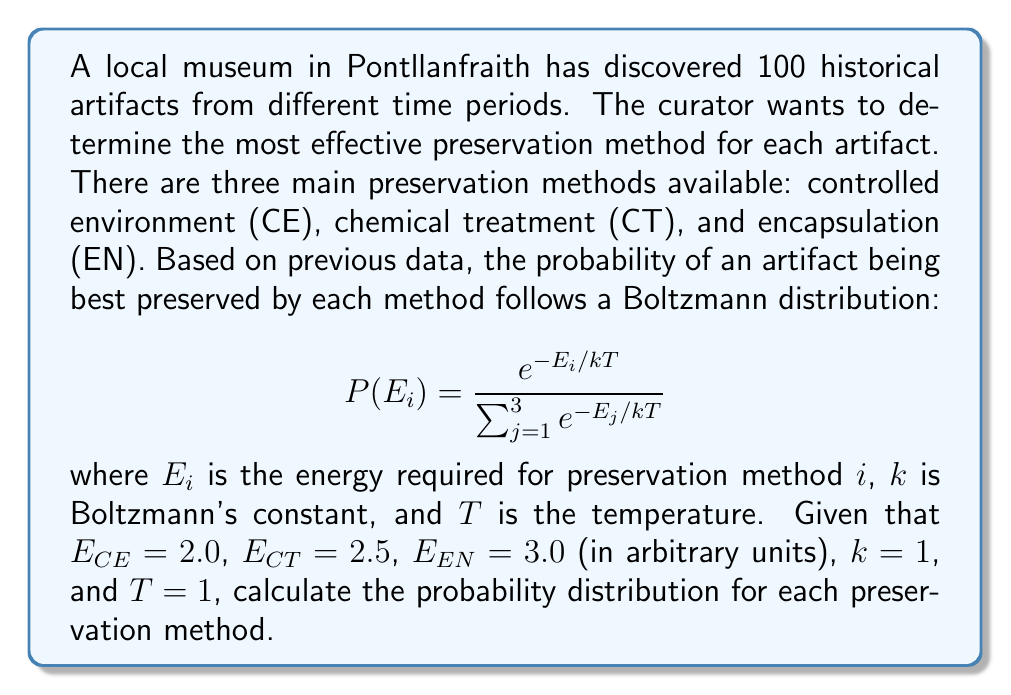Provide a solution to this math problem. To solve this problem, we need to follow these steps:

1. Calculate the denominator (partition function) of the Boltzmann distribution:
   $$Z = \sum_{j=1}^3 e^{-E_j/kT} = e^{-E_{CE}/kT} + e^{-E_{CT}/kT} + e^{-E_{EN}/kT}$$

2. Calculate the probability for each preservation method using the Boltzmann distribution formula.

Step 1: Calculate the partition function Z

$$\begin{align}
Z &= e^{-2.0/1} + e^{-2.5/1} + e^{-3.0/1} \\
&= e^{-2.0} + e^{-2.5} + e^{-3.0} \\
&= 0.1353 + 0.0821 + 0.0498 \\
&= 0.2672
\end{align}$$

Step 2: Calculate the probability for each method

For Controlled Environment (CE):
$$P(CE) = \frac{e^{-2.0/1}}{0.2672} = \frac{0.1353}{0.2672} = 0.5063$$

For Chemical Treatment (CT):
$$P(CT) = \frac{e^{-2.5/1}}{0.2672} = \frac{0.0821}{0.2672} = 0.3072$$

For Encapsulation (EN):
$$P(EN) = \frac{e^{-3.0/1}}{0.2672} = \frac{0.0498}{0.2672} = 0.1865$$

We can verify that the probabilities sum to 1:
$$0.5063 + 0.3072 + 0.1865 = 1.0000$$
Answer: $P(CE) = 0.5063, P(CT) = 0.3072, P(EN) = 0.1865$ 